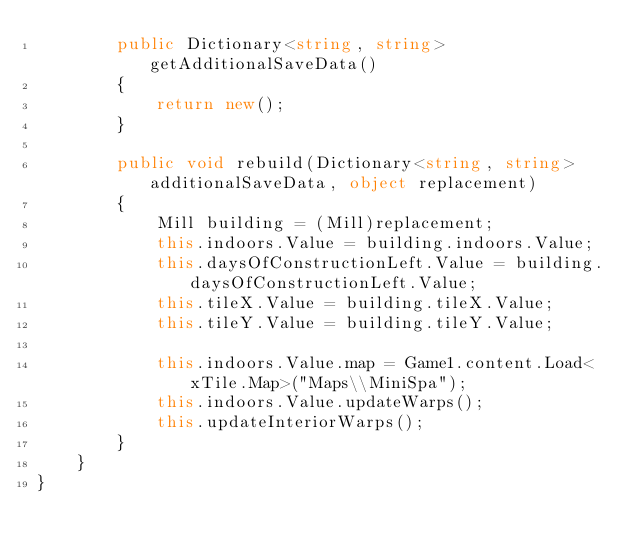<code> <loc_0><loc_0><loc_500><loc_500><_C#_>        public Dictionary<string, string> getAdditionalSaveData()
        {
            return new();
        }

        public void rebuild(Dictionary<string, string> additionalSaveData, object replacement)
        {
            Mill building = (Mill)replacement;
            this.indoors.Value = building.indoors.Value;
            this.daysOfConstructionLeft.Value = building.daysOfConstructionLeft.Value;
            this.tileX.Value = building.tileX.Value;
            this.tileY.Value = building.tileY.Value;

            this.indoors.Value.map = Game1.content.Load<xTile.Map>("Maps\\MiniSpa");
            this.indoors.Value.updateWarps();
            this.updateInteriorWarps();
        }
    }
}
</code> 